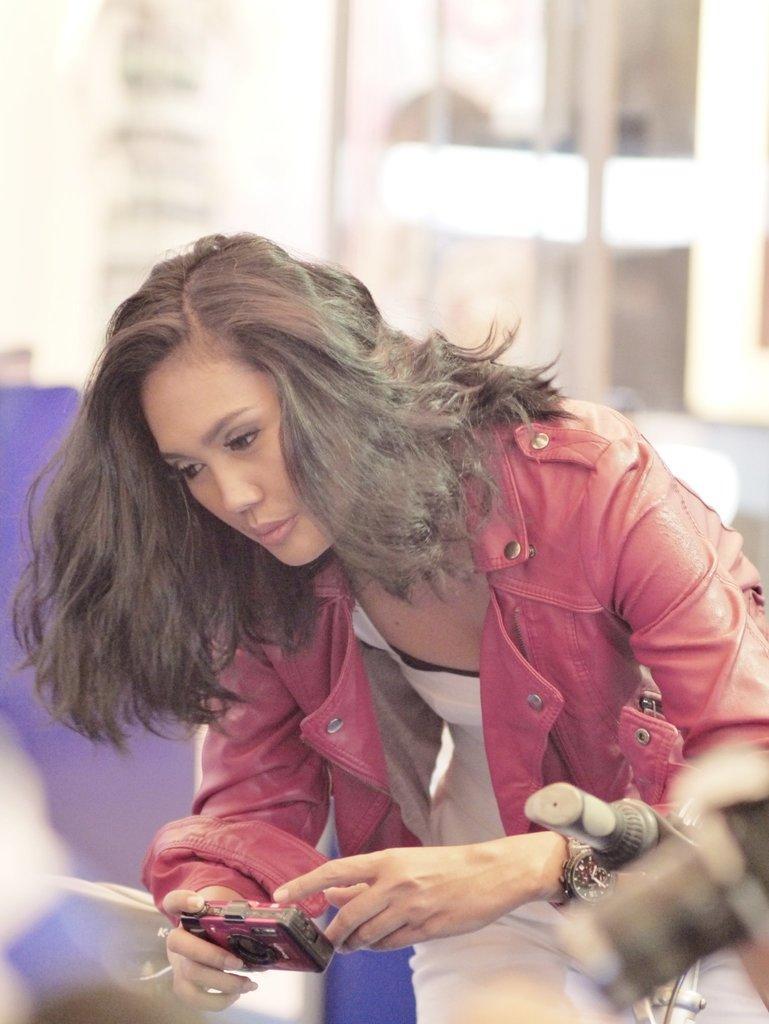Could you give a brief overview of what you see in this image? In the center we can see one woman she is holding camera. 